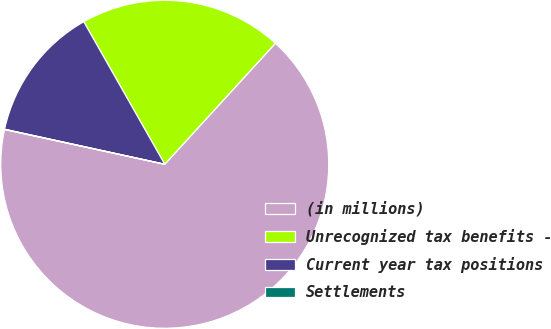<chart> <loc_0><loc_0><loc_500><loc_500><pie_chart><fcel>(in millions)<fcel>Unrecognized tax benefits -<fcel>Current year tax positions<fcel>Settlements<nl><fcel>66.61%<fcel>20.01%<fcel>13.35%<fcel>0.03%<nl></chart> 